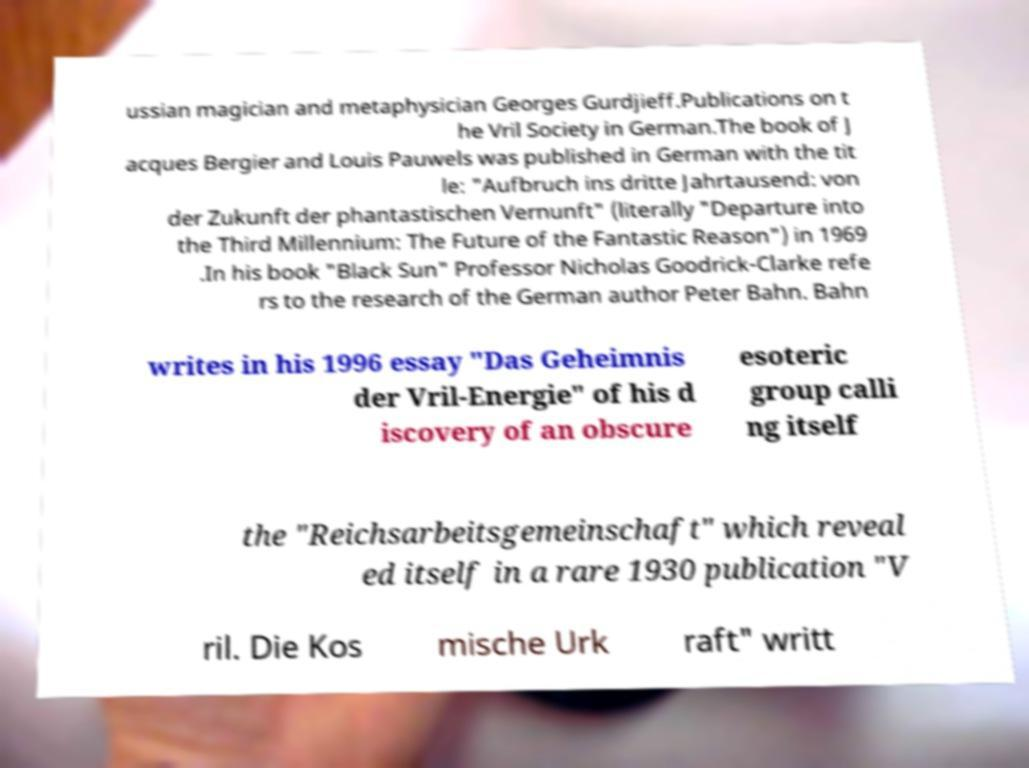Could you assist in decoding the text presented in this image and type it out clearly? ussian magician and metaphysician Georges Gurdjieff.Publications on t he Vril Society in German.The book of J acques Bergier and Louis Pauwels was published in German with the tit le: "Aufbruch ins dritte Jahrtausend: von der Zukunft der phantastischen Vernunft" (literally "Departure into the Third Millennium: The Future of the Fantastic Reason") in 1969 .In his book "Black Sun" Professor Nicholas Goodrick-Clarke refe rs to the research of the German author Peter Bahn. Bahn writes in his 1996 essay "Das Geheimnis der Vril-Energie" of his d iscovery of an obscure esoteric group calli ng itself the "Reichsarbeitsgemeinschaft" which reveal ed itself in a rare 1930 publication "V ril. Die Kos mische Urk raft" writt 